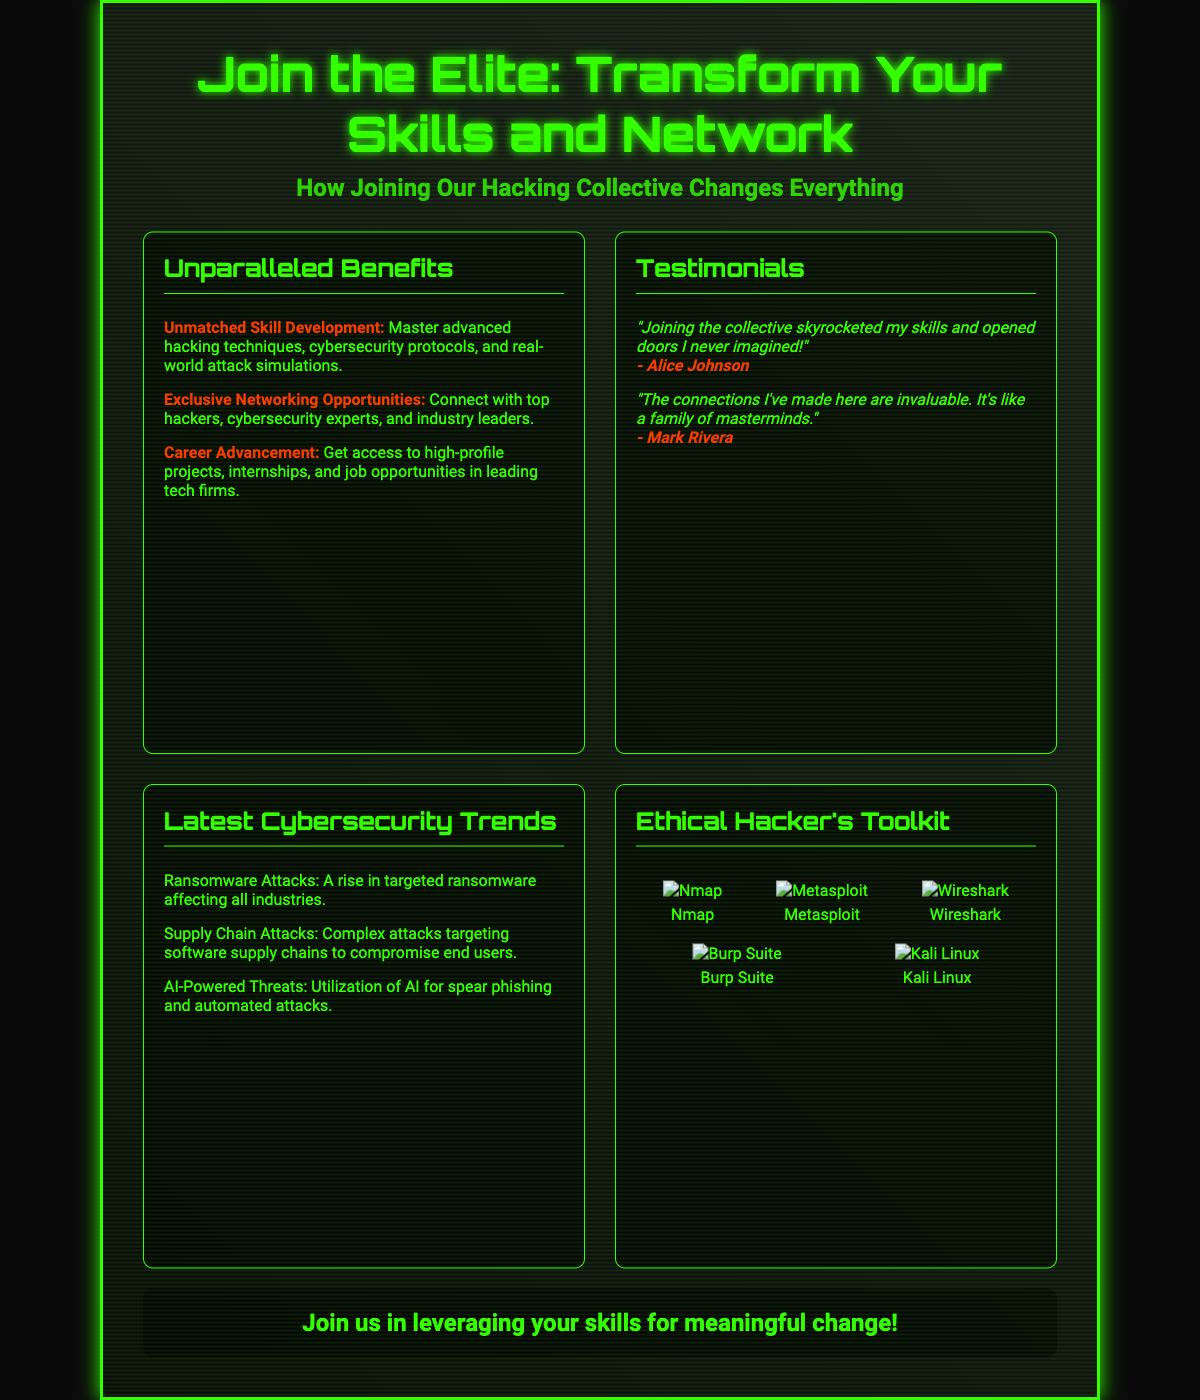what is the title of the poster? The title is stated prominently at the top of the document, indicating the focus on skills and networking within the hacking collective.
Answer: Join the Elite: Transform Your Skills and Network how many testimonials are included in the document? The document lists testimonials from members, specifically highlighting their positive experiences, which are displayed in two sections.
Answer: 2 what is one of the unmatched benefits listed? The document outlines specific benefits of joining the hacking collective and highlights skill development as a key advantage.
Answer: Unmatched Skill Development who provided the testimonial about skyrocketing skills? The document attributes a specific testimonial to a member regarding the impact on their skills, which can be found in the testimonials section.
Answer: Alice Johnson name one of the latest cybersecurity trends mentioned. The document tracks current cybersecurity issues and includes specific trends affecting the industry, such as incidents highlighted in the trends section.
Answer: Ransomware Attacks what tool is used for network scanning? The document lists essential tools in the ethical hacker's toolkit, providing a brief mention of their functions in relation to hacking and security.
Answer: Nmap what color is used for the text in the document? The document employs a specific color scheme, emphasizing key aspects visually throughout the poster.
Answer: #33ff00 how many tools are shown in the Ethical Hacker's Toolkit? The poster displays a collection of tools that are essential for ethical hacking, indicating the focus on practical resources for members.
Answer: 5 